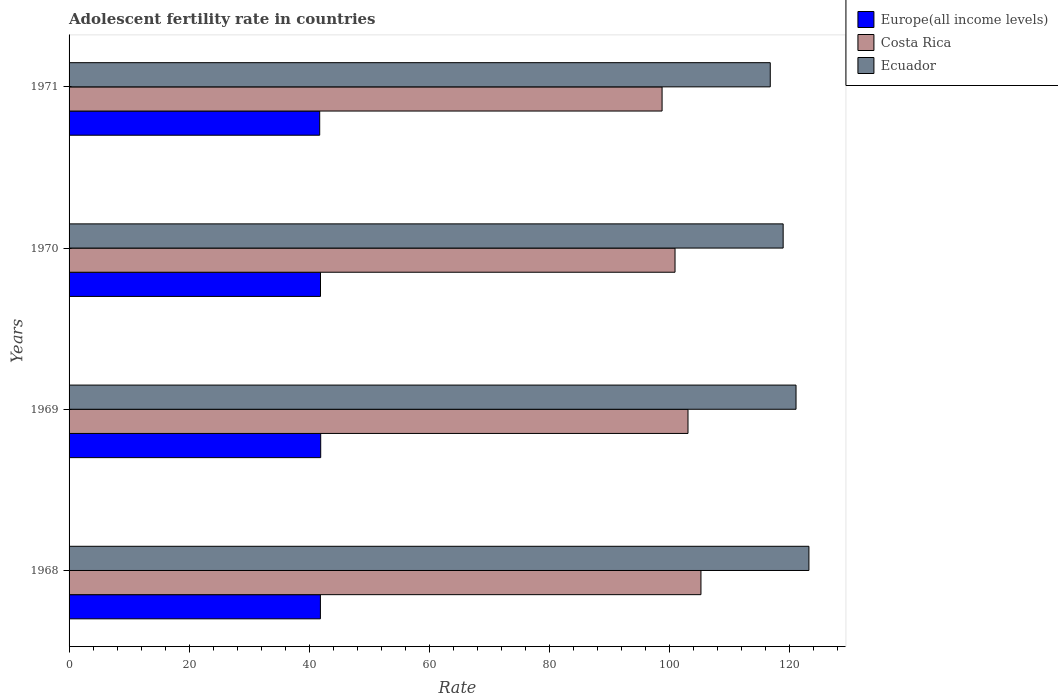How many bars are there on the 3rd tick from the top?
Offer a terse response. 3. How many bars are there on the 2nd tick from the bottom?
Give a very brief answer. 3. What is the label of the 2nd group of bars from the top?
Your answer should be compact. 1970. In how many cases, is the number of bars for a given year not equal to the number of legend labels?
Provide a succinct answer. 0. What is the adolescent fertility rate in Costa Rica in 1968?
Your response must be concise. 105.26. Across all years, what is the maximum adolescent fertility rate in Europe(all income levels)?
Provide a short and direct response. 41.92. Across all years, what is the minimum adolescent fertility rate in Europe(all income levels)?
Offer a very short reply. 41.75. In which year was the adolescent fertility rate in Ecuador maximum?
Keep it short and to the point. 1968. What is the total adolescent fertility rate in Europe(all income levels) in the graph?
Your response must be concise. 167.41. What is the difference between the adolescent fertility rate in Costa Rica in 1968 and that in 1969?
Offer a very short reply. 2.16. What is the difference between the adolescent fertility rate in Ecuador in 1971 and the adolescent fertility rate in Europe(all income levels) in 1969?
Offer a very short reply. 74.89. What is the average adolescent fertility rate in Costa Rica per year?
Make the answer very short. 102.02. In the year 1971, what is the difference between the adolescent fertility rate in Ecuador and adolescent fertility rate in Costa Rica?
Your answer should be very brief. 18.02. In how many years, is the adolescent fertility rate in Costa Rica greater than 56 ?
Ensure brevity in your answer.  4. What is the ratio of the adolescent fertility rate in Ecuador in 1968 to that in 1970?
Provide a succinct answer. 1.04. Is the difference between the adolescent fertility rate in Ecuador in 1969 and 1971 greater than the difference between the adolescent fertility rate in Costa Rica in 1969 and 1971?
Keep it short and to the point. No. What is the difference between the highest and the second highest adolescent fertility rate in Ecuador?
Make the answer very short. 2.15. What is the difference between the highest and the lowest adolescent fertility rate in Europe(all income levels)?
Offer a terse response. 0.17. Is the sum of the adolescent fertility rate in Europe(all income levels) in 1968 and 1971 greater than the maximum adolescent fertility rate in Ecuador across all years?
Give a very brief answer. No. What does the 3rd bar from the top in 1971 represents?
Your answer should be very brief. Europe(all income levels). Is it the case that in every year, the sum of the adolescent fertility rate in Costa Rica and adolescent fertility rate in Ecuador is greater than the adolescent fertility rate in Europe(all income levels)?
Make the answer very short. Yes. Are the values on the major ticks of X-axis written in scientific E-notation?
Offer a terse response. No. How many legend labels are there?
Provide a short and direct response. 3. What is the title of the graph?
Ensure brevity in your answer.  Adolescent fertility rate in countries. Does "United Arab Emirates" appear as one of the legend labels in the graph?
Offer a very short reply. No. What is the label or title of the X-axis?
Offer a very short reply. Rate. What is the Rate in Europe(all income levels) in 1968?
Keep it short and to the point. 41.87. What is the Rate of Costa Rica in 1968?
Provide a short and direct response. 105.26. What is the Rate in Ecuador in 1968?
Make the answer very short. 123.24. What is the Rate of Europe(all income levels) in 1969?
Provide a short and direct response. 41.92. What is the Rate in Costa Rica in 1969?
Provide a succinct answer. 103.1. What is the Rate in Ecuador in 1969?
Offer a very short reply. 121.1. What is the Rate of Europe(all income levels) in 1970?
Provide a succinct answer. 41.88. What is the Rate in Costa Rica in 1970?
Your response must be concise. 100.94. What is the Rate in Ecuador in 1970?
Offer a terse response. 118.95. What is the Rate of Europe(all income levels) in 1971?
Provide a short and direct response. 41.75. What is the Rate of Costa Rica in 1971?
Offer a terse response. 98.78. What is the Rate of Ecuador in 1971?
Keep it short and to the point. 116.8. Across all years, what is the maximum Rate in Europe(all income levels)?
Offer a very short reply. 41.92. Across all years, what is the maximum Rate of Costa Rica?
Offer a terse response. 105.26. Across all years, what is the maximum Rate in Ecuador?
Give a very brief answer. 123.24. Across all years, what is the minimum Rate of Europe(all income levels)?
Offer a terse response. 41.75. Across all years, what is the minimum Rate of Costa Rica?
Provide a short and direct response. 98.78. Across all years, what is the minimum Rate of Ecuador?
Your answer should be very brief. 116.8. What is the total Rate of Europe(all income levels) in the graph?
Make the answer very short. 167.41. What is the total Rate in Costa Rica in the graph?
Provide a short and direct response. 408.08. What is the total Rate of Ecuador in the graph?
Offer a terse response. 480.09. What is the difference between the Rate of Europe(all income levels) in 1968 and that in 1969?
Provide a succinct answer. -0.05. What is the difference between the Rate of Costa Rica in 1968 and that in 1969?
Your response must be concise. 2.16. What is the difference between the Rate of Ecuador in 1968 and that in 1969?
Keep it short and to the point. 2.15. What is the difference between the Rate of Europe(all income levels) in 1968 and that in 1970?
Provide a succinct answer. -0.02. What is the difference between the Rate of Costa Rica in 1968 and that in 1970?
Provide a succinct answer. 4.32. What is the difference between the Rate of Ecuador in 1968 and that in 1970?
Offer a very short reply. 4.29. What is the difference between the Rate in Europe(all income levels) in 1968 and that in 1971?
Ensure brevity in your answer.  0.12. What is the difference between the Rate of Costa Rica in 1968 and that in 1971?
Your answer should be compact. 6.48. What is the difference between the Rate in Ecuador in 1968 and that in 1971?
Your answer should be very brief. 6.44. What is the difference between the Rate of Europe(all income levels) in 1969 and that in 1970?
Offer a terse response. 0.04. What is the difference between the Rate in Costa Rica in 1969 and that in 1970?
Offer a terse response. 2.16. What is the difference between the Rate of Ecuador in 1969 and that in 1970?
Ensure brevity in your answer.  2.15. What is the difference between the Rate in Europe(all income levels) in 1969 and that in 1971?
Offer a terse response. 0.17. What is the difference between the Rate of Costa Rica in 1969 and that in 1971?
Your response must be concise. 4.32. What is the difference between the Rate of Ecuador in 1969 and that in 1971?
Provide a short and direct response. 4.29. What is the difference between the Rate of Europe(all income levels) in 1970 and that in 1971?
Give a very brief answer. 0.13. What is the difference between the Rate of Costa Rica in 1970 and that in 1971?
Your answer should be very brief. 2.16. What is the difference between the Rate in Ecuador in 1970 and that in 1971?
Make the answer very short. 2.15. What is the difference between the Rate of Europe(all income levels) in 1968 and the Rate of Costa Rica in 1969?
Your answer should be compact. -61.23. What is the difference between the Rate in Europe(all income levels) in 1968 and the Rate in Ecuador in 1969?
Make the answer very short. -79.23. What is the difference between the Rate in Costa Rica in 1968 and the Rate in Ecuador in 1969?
Give a very brief answer. -15.84. What is the difference between the Rate of Europe(all income levels) in 1968 and the Rate of Costa Rica in 1970?
Give a very brief answer. -59.07. What is the difference between the Rate in Europe(all income levels) in 1968 and the Rate in Ecuador in 1970?
Offer a terse response. -77.08. What is the difference between the Rate of Costa Rica in 1968 and the Rate of Ecuador in 1970?
Provide a succinct answer. -13.69. What is the difference between the Rate in Europe(all income levels) in 1968 and the Rate in Costa Rica in 1971?
Offer a terse response. -56.92. What is the difference between the Rate in Europe(all income levels) in 1968 and the Rate in Ecuador in 1971?
Offer a very short reply. -74.94. What is the difference between the Rate in Costa Rica in 1968 and the Rate in Ecuador in 1971?
Your answer should be compact. -11.55. What is the difference between the Rate in Europe(all income levels) in 1969 and the Rate in Costa Rica in 1970?
Your response must be concise. -59.02. What is the difference between the Rate in Europe(all income levels) in 1969 and the Rate in Ecuador in 1970?
Your answer should be very brief. -77.03. What is the difference between the Rate of Costa Rica in 1969 and the Rate of Ecuador in 1970?
Your answer should be very brief. -15.85. What is the difference between the Rate in Europe(all income levels) in 1969 and the Rate in Costa Rica in 1971?
Provide a succinct answer. -56.86. What is the difference between the Rate of Europe(all income levels) in 1969 and the Rate of Ecuador in 1971?
Make the answer very short. -74.89. What is the difference between the Rate of Costa Rica in 1969 and the Rate of Ecuador in 1971?
Make the answer very short. -13.71. What is the difference between the Rate of Europe(all income levels) in 1970 and the Rate of Costa Rica in 1971?
Ensure brevity in your answer.  -56.9. What is the difference between the Rate of Europe(all income levels) in 1970 and the Rate of Ecuador in 1971?
Your answer should be very brief. -74.92. What is the difference between the Rate of Costa Rica in 1970 and the Rate of Ecuador in 1971?
Make the answer very short. -15.86. What is the average Rate of Europe(all income levels) per year?
Make the answer very short. 41.85. What is the average Rate in Costa Rica per year?
Provide a short and direct response. 102.02. What is the average Rate in Ecuador per year?
Your answer should be compact. 120.02. In the year 1968, what is the difference between the Rate of Europe(all income levels) and Rate of Costa Rica?
Offer a terse response. -63.39. In the year 1968, what is the difference between the Rate of Europe(all income levels) and Rate of Ecuador?
Your answer should be compact. -81.38. In the year 1968, what is the difference between the Rate of Costa Rica and Rate of Ecuador?
Your answer should be compact. -17.99. In the year 1969, what is the difference between the Rate of Europe(all income levels) and Rate of Costa Rica?
Offer a terse response. -61.18. In the year 1969, what is the difference between the Rate in Europe(all income levels) and Rate in Ecuador?
Provide a succinct answer. -79.18. In the year 1969, what is the difference between the Rate in Costa Rica and Rate in Ecuador?
Ensure brevity in your answer.  -18. In the year 1970, what is the difference between the Rate in Europe(all income levels) and Rate in Costa Rica?
Provide a succinct answer. -59.06. In the year 1970, what is the difference between the Rate in Europe(all income levels) and Rate in Ecuador?
Ensure brevity in your answer.  -77.07. In the year 1970, what is the difference between the Rate of Costa Rica and Rate of Ecuador?
Your answer should be very brief. -18.01. In the year 1971, what is the difference between the Rate in Europe(all income levels) and Rate in Costa Rica?
Your answer should be compact. -57.03. In the year 1971, what is the difference between the Rate in Europe(all income levels) and Rate in Ecuador?
Your answer should be compact. -75.06. In the year 1971, what is the difference between the Rate of Costa Rica and Rate of Ecuador?
Ensure brevity in your answer.  -18.02. What is the ratio of the Rate in Costa Rica in 1968 to that in 1969?
Give a very brief answer. 1.02. What is the ratio of the Rate of Ecuador in 1968 to that in 1969?
Your answer should be compact. 1.02. What is the ratio of the Rate of Costa Rica in 1968 to that in 1970?
Your answer should be very brief. 1.04. What is the ratio of the Rate in Ecuador in 1968 to that in 1970?
Provide a short and direct response. 1.04. What is the ratio of the Rate of Europe(all income levels) in 1968 to that in 1971?
Ensure brevity in your answer.  1. What is the ratio of the Rate in Costa Rica in 1968 to that in 1971?
Offer a terse response. 1.07. What is the ratio of the Rate in Ecuador in 1968 to that in 1971?
Your response must be concise. 1.06. What is the ratio of the Rate in Europe(all income levels) in 1969 to that in 1970?
Your answer should be very brief. 1. What is the ratio of the Rate in Costa Rica in 1969 to that in 1970?
Your answer should be very brief. 1.02. What is the ratio of the Rate in Ecuador in 1969 to that in 1970?
Provide a succinct answer. 1.02. What is the ratio of the Rate in Costa Rica in 1969 to that in 1971?
Make the answer very short. 1.04. What is the ratio of the Rate in Ecuador in 1969 to that in 1971?
Provide a succinct answer. 1.04. What is the ratio of the Rate of Europe(all income levels) in 1970 to that in 1971?
Make the answer very short. 1. What is the ratio of the Rate of Costa Rica in 1970 to that in 1971?
Provide a succinct answer. 1.02. What is the ratio of the Rate in Ecuador in 1970 to that in 1971?
Make the answer very short. 1.02. What is the difference between the highest and the second highest Rate of Europe(all income levels)?
Offer a terse response. 0.04. What is the difference between the highest and the second highest Rate of Costa Rica?
Give a very brief answer. 2.16. What is the difference between the highest and the second highest Rate of Ecuador?
Offer a very short reply. 2.15. What is the difference between the highest and the lowest Rate in Europe(all income levels)?
Offer a terse response. 0.17. What is the difference between the highest and the lowest Rate of Costa Rica?
Offer a terse response. 6.48. What is the difference between the highest and the lowest Rate of Ecuador?
Make the answer very short. 6.44. 